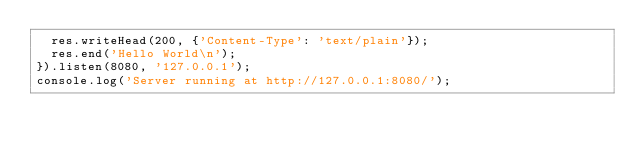<code> <loc_0><loc_0><loc_500><loc_500><_JavaScript_>	res.writeHead(200, {'Content-Type': 'text/plain'});
	res.end('Hello World\n');
}).listen(8080, '127.0.0.1');
console.log('Server running at http://127.0.0.1:8080/');
</code> 